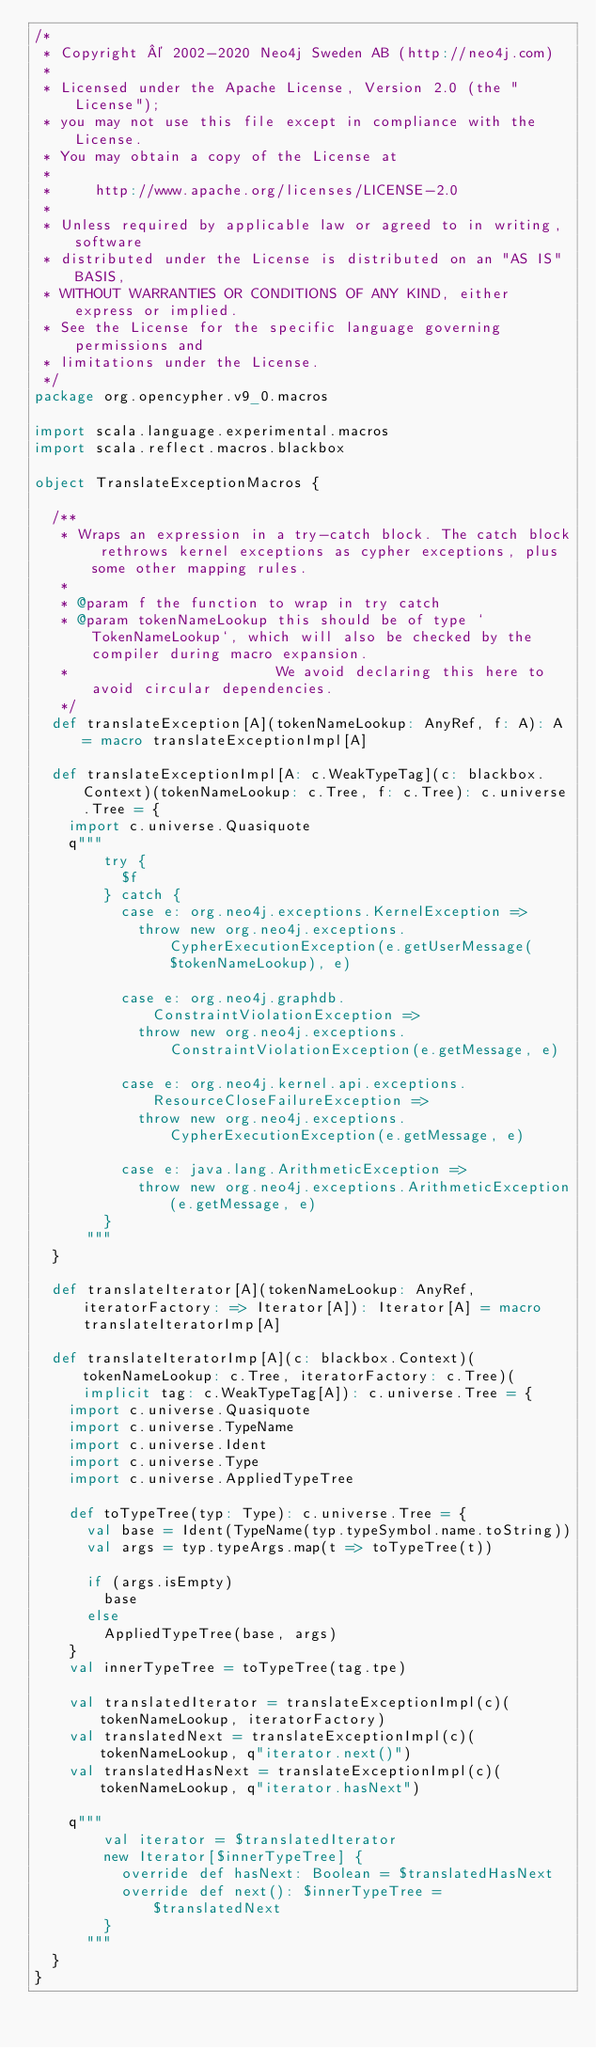Convert code to text. <code><loc_0><loc_0><loc_500><loc_500><_Scala_>/*
 * Copyright © 2002-2020 Neo4j Sweden AB (http://neo4j.com)
 *
 * Licensed under the Apache License, Version 2.0 (the "License");
 * you may not use this file except in compliance with the License.
 * You may obtain a copy of the License at
 *
 *     http://www.apache.org/licenses/LICENSE-2.0
 *
 * Unless required by applicable law or agreed to in writing, software
 * distributed under the License is distributed on an "AS IS" BASIS,
 * WITHOUT WARRANTIES OR CONDITIONS OF ANY KIND, either express or implied.
 * See the License for the specific language governing permissions and
 * limitations under the License.
 */
package org.opencypher.v9_0.macros

import scala.language.experimental.macros
import scala.reflect.macros.blackbox

object TranslateExceptionMacros {

  /**
   * Wraps an expression in a try-catch block. The catch block rethrows kernel exceptions as cypher exceptions, plus some other mapping rules.
   *
   * @param f the function to wrap in try catch
   * @param tokenNameLookup this should be of type `TokenNameLookup`, which will also be checked by the compiler during macro expansion.
   *                        We avoid declaring this here to avoid circular dependencies.
   */
  def translateException[A](tokenNameLookup: AnyRef, f: A): A = macro translateExceptionImpl[A]

  def translateExceptionImpl[A: c.WeakTypeTag](c: blackbox.Context)(tokenNameLookup: c.Tree, f: c.Tree): c.universe.Tree = {
    import c.universe.Quasiquote
    q"""
        try {
          $f
        } catch {
          case e: org.neo4j.exceptions.KernelException =>
            throw new org.neo4j.exceptions.CypherExecutionException(e.getUserMessage($tokenNameLookup), e)

          case e: org.neo4j.graphdb.ConstraintViolationException =>
            throw new org.neo4j.exceptions.ConstraintViolationException(e.getMessage, e)

          case e: org.neo4j.kernel.api.exceptions.ResourceCloseFailureException =>
            throw new org.neo4j.exceptions.CypherExecutionException(e.getMessage, e)

          case e: java.lang.ArithmeticException =>
            throw new org.neo4j.exceptions.ArithmeticException(e.getMessage, e)
        }
      """
  }

  def translateIterator[A](tokenNameLookup: AnyRef, iteratorFactory: => Iterator[A]): Iterator[A] = macro translateIteratorImp[A]

  def translateIteratorImp[A](c: blackbox.Context)(tokenNameLookup: c.Tree, iteratorFactory: c.Tree)(implicit tag: c.WeakTypeTag[A]): c.universe.Tree = {
    import c.universe.Quasiquote
    import c.universe.TypeName
    import c.universe.Ident
    import c.universe.Type
    import c.universe.AppliedTypeTree

    def toTypeTree(typ: Type): c.universe.Tree = {
      val base = Ident(TypeName(typ.typeSymbol.name.toString))
      val args = typ.typeArgs.map(t => toTypeTree(t))

      if (args.isEmpty)
        base
      else
        AppliedTypeTree(base, args)
    }
    val innerTypeTree = toTypeTree(tag.tpe)

    val translatedIterator = translateExceptionImpl(c)(tokenNameLookup, iteratorFactory)
    val translatedNext = translateExceptionImpl(c)(tokenNameLookup, q"iterator.next()")
    val translatedHasNext = translateExceptionImpl(c)(tokenNameLookup, q"iterator.hasNext")

    q"""
        val iterator = $translatedIterator
        new Iterator[$innerTypeTree] {
          override def hasNext: Boolean = $translatedHasNext
          override def next(): $innerTypeTree = $translatedNext
        }
      """
  }
}
</code> 